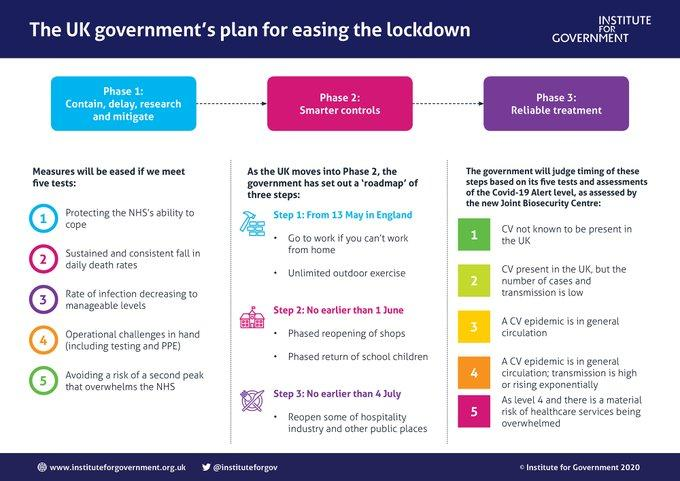Draw attention to some important aspects in this diagram. The reliable treatment is comprised of five key points. The number of steps listed under Phase 2 is 3. 